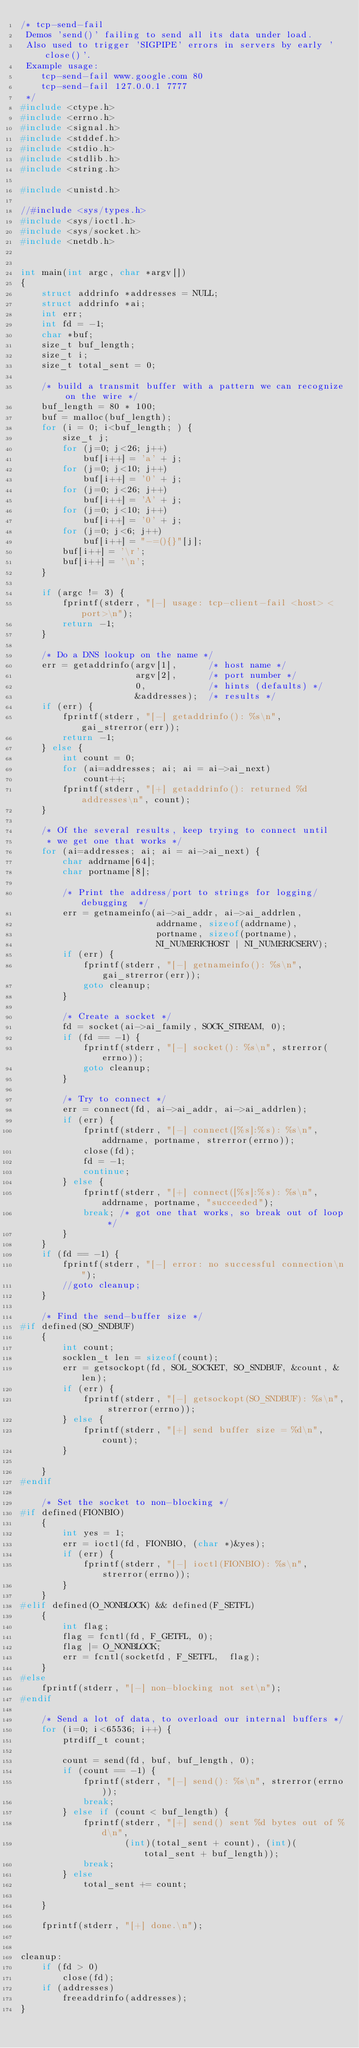<code> <loc_0><loc_0><loc_500><loc_500><_C_>/* tcp-send-fail
 Demos 'send()' failing to send all its data under load.
 Also used to trigger 'SIGPIPE' errors in servers by early 'close()'.
 Example usage:
    tcp-send-fail www.google.com 80
    tcp-send-fail 127.0.0.1 7777
 */
#include <ctype.h>
#include <errno.h>
#include <signal.h>
#include <stddef.h>
#include <stdio.h>
#include <stdlib.h>
#include <string.h>

#include <unistd.h>

//#include <sys/types.h>
#include <sys/ioctl.h>
#include <sys/socket.h>
#include <netdb.h>


int main(int argc, char *argv[])
{
    struct addrinfo *addresses = NULL;
    struct addrinfo *ai;
    int err;
    int fd = -1;
    char *buf;
    size_t buf_length;
    size_t i;
    size_t total_sent = 0;
    
    /* build a transmit buffer with a pattern we can recognize on the wire */
    buf_length = 80 * 100;
    buf = malloc(buf_length);
    for (i = 0; i<buf_length; ) {
        size_t j;
        for (j=0; j<26; j++)
            buf[i++] = 'a' + j;
        for (j=0; j<10; j++)
            buf[i++] = '0' + j;
        for (j=0; j<26; j++)
            buf[i++] = 'A' + j;
        for (j=0; j<10; j++)
            buf[i++] = '0' + j;
        for (j=0; j<6; j++)
            buf[i++] = "-=(){}"[j];
        buf[i++] = '\r';
        buf[i++] = '\n';
    }

    if (argc != 3) {
        fprintf(stderr, "[-] usage: tcp-client-fail <host> <port>\n");
        return -1;
    }
    
    /* Do a DNS lookup on the name */
    err = getaddrinfo(argv[1],      /* host name */
                      argv[2],      /* port number */
                      0,            /* hints (defaults) */
                      &addresses);  /* results */
    if (err) {
        fprintf(stderr, "[-] getaddrinfo(): %s\n", gai_strerror(err));
        return -1;
    } else {
	    int count = 0;
	    for (ai=addresses; ai; ai = ai->ai_next)
	        count++;
	    fprintf(stderr, "[+] getaddrinfo(): returned %d addresses\n", count);
    }
    
    /* Of the several results, keep trying to connect until
     * we get one that works */
    for (ai=addresses; ai; ai = ai->ai_next) {
        char addrname[64];
        char portname[8];
        
        /* Print the address/port to strings for logging/debugging  */
        err = getnameinfo(ai->ai_addr, ai->ai_addrlen,
                          addrname, sizeof(addrname),
                          portname, sizeof(portname),
                          NI_NUMERICHOST | NI_NUMERICSERV);
        if (err) {
            fprintf(stderr, "[-] getnameinfo(): %s\n", gai_strerror(err));
            goto cleanup;
        }
        
        /* Create a socket */
        fd = socket(ai->ai_family, SOCK_STREAM, 0);
        if (fd == -1) {
            fprintf(stderr, "[-] socket(): %s\n", strerror(errno));
            goto cleanup;
        }
        
        /* Try to connect */
        err = connect(fd, ai->ai_addr, ai->ai_addrlen);
        if (err) {
            fprintf(stderr, "[-] connect([%s]:%s): %s\n", addrname, portname, strerror(errno));
            close(fd);
            fd = -1;
            continue;
        } else {
            fprintf(stderr, "[+] connect([%s]:%s): %s\n", addrname, portname, "succeeded");
            break; /* got one that works, so break out of loop */
        }
    }
    if (fd == -1) {
        fprintf(stderr, "[-] error: no successful connection\n");
        //goto cleanup;
    }

    /* Find the send-buffer size */
#if defined(SO_SNDBUF)
    {
        int count;
        socklen_t len = sizeof(count);
        err = getsockopt(fd, SOL_SOCKET, SO_SNDBUF, &count, &len);
        if (err) {
            fprintf(stderr, "[-] getsockopt(SO_SNDBUF): %s\n", strerror(errno));
        } else {
            fprintf(stderr, "[+] send buffer size = %d\n", count);
        }

    }
#endif

    /* Set the socket to non-blocking */
#if defined(FIONBIO)
    {
        int yes = 1;
        err = ioctl(fd, FIONBIO, (char *)&yes);
        if (err) {
            fprintf(stderr, "[-] ioctl(FIONBIO): %s\n", strerror(errno));
        }
    }
#elif defined(O_NONBLOCK) && defined(F_SETFL)
    {
        int flag;
        flag = fcntl(fd, F_GETFL, 0);
        flag |= O_NONBLOCK;
        err = fcntl(socketfd, F_SETFL,  flag);
    }
#else
    fprintf(stderr, "[-] non-blocking not set\n");
#endif

    /* Send a lot of data, to overload our internal buffers */    
    for (i=0; i<65536; i++) {
        ptrdiff_t count;

        count = send(fd, buf, buf_length, 0);
        if (count == -1) {
            fprintf(stderr, "[-] send(): %s\n", strerror(errno));
            break;
        } else if (count < buf_length) {
            fprintf(stderr, "[+] send() sent %d bytes out of %d\n", 
                    (int)(total_sent + count), (int)(total_sent + buf_length));
            break;
        } else
            total_sent += count;

    }

    fprintf(stderr, "[+] done.\n");


cleanup:
    if (fd > 0)
        close(fd);
    if (addresses)
        freeaddrinfo(addresses);
}

</code> 